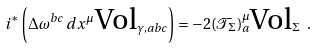<formula> <loc_0><loc_0><loc_500><loc_500>i ^ { \ast } \left ( \Delta { \omega } ^ { b c } \, d x ^ { \mu } \, \text {Vol} _ { \gamma , a b c } \right ) = - 2 ( \mathcal { T } _ { \Sigma } ) _ { a } ^ { \mu } \text {Vol} _ { \Sigma } \ .</formula> 